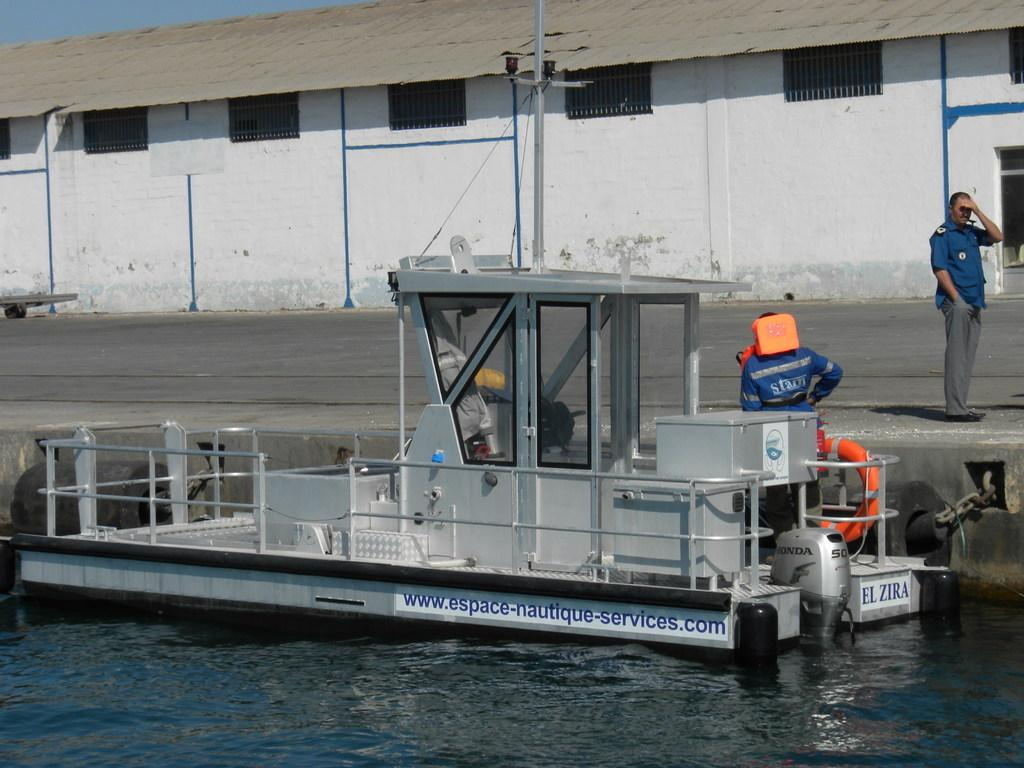What is the main feature of the image? There is water in the image. What is on the water? There is a boat on the water. Who or what is present in the image? There are people in the image. What can be seen in the background of the image? There is a shed in the background of the image. What is visible at the top of the image? The sky is visible at the top of the image. Where are the flowers growing in the image? There are no flowers present in the image. Is there a hill visible in the image? There is no hill visible in the image. --- Facts: 1. There is a person holding a book in the image. 2. The person is sitting on a chair. 3. There is a table in the image. 4. The table has a lamp on it. 5. There is a window in the background of the image. Absurd Topics: parrot, bicycle, ocean Conversation: What is the person in the image holding? The person is holding a book in the image. What is the person's position in the image? The person is sitting on a chair. What is present in the image besides the person? There is a table in the image. What is on the table? The table has a lamp on it. What can be seen in the background of the image? There is a window in the background of the image. Reasoning: Let's think step by step in order to produce the conversation. We start by identifying the main subject in the image, which is the person holding a book. Then, we describe the person's position and the presence of a table in the image. Next, we mention the lamp on the table and the window in the background. Each question is designed to elicit a specific detail about the image that is known from the provided facts. Absurd Question/Answer: Can you see a parrot sitting on the person's shoulder in the image? There is no parrot present in the image. Is there an ocean visible through the window in the image? There is no ocean visible in the image; only a window is present in the background. 